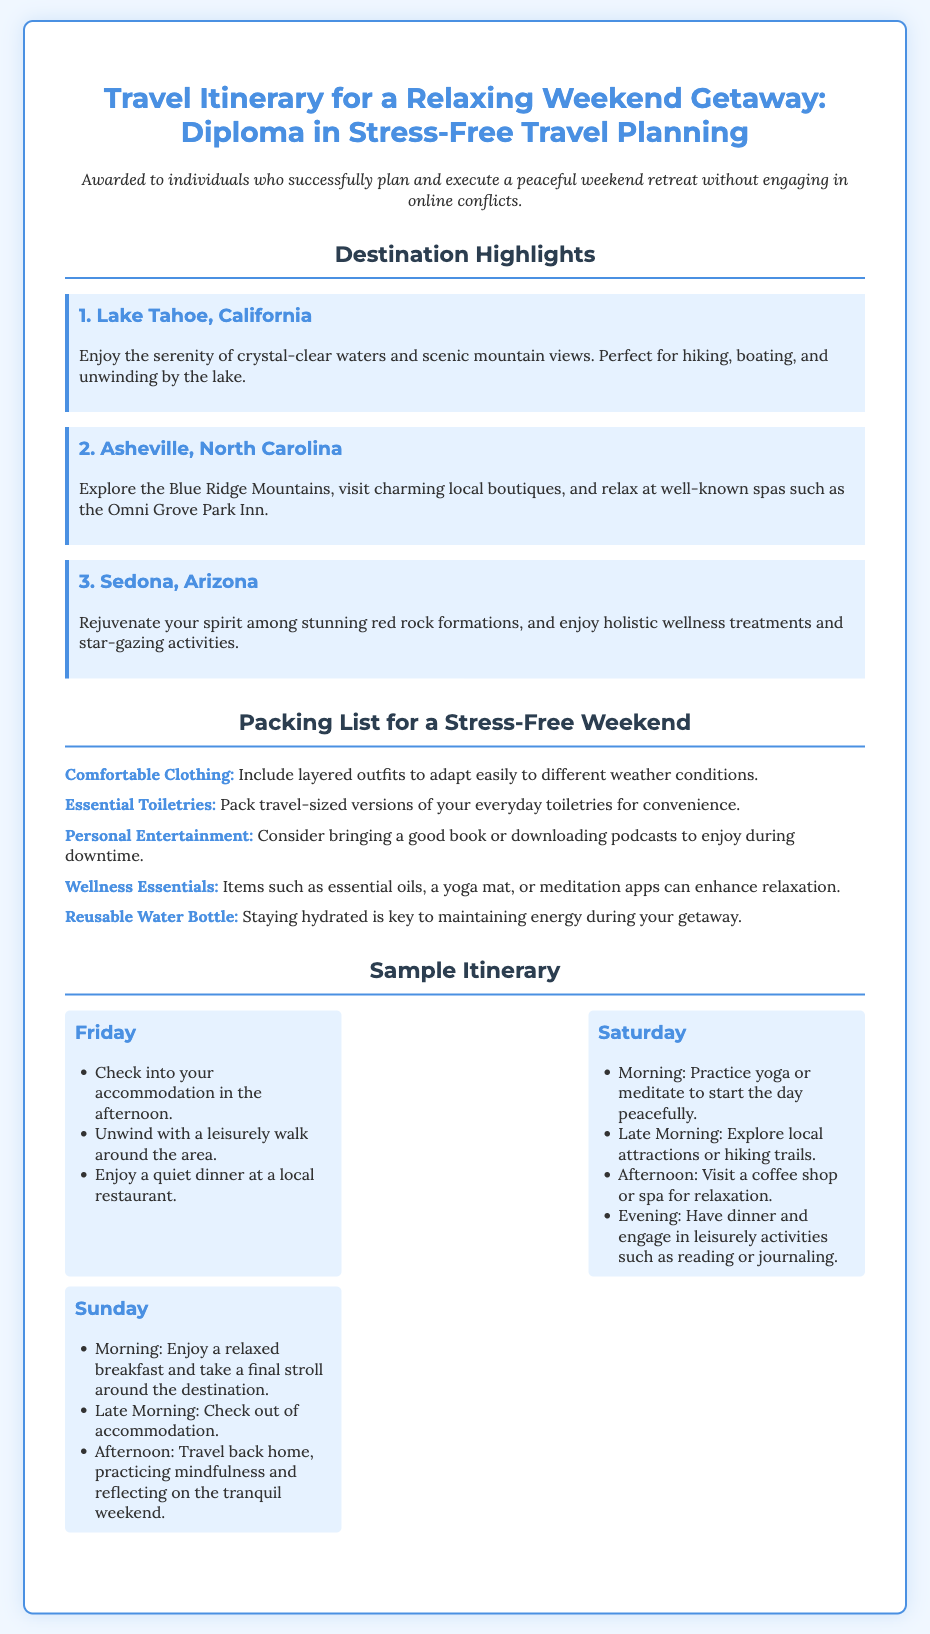What is the title of the document? The title is prominently displayed at the top of the document, indicating the subject of the content.
Answer: Travel Itinerary for a Relaxing Weekend Getaway: Diploma in Stress-Free Travel Planning How many destination highlights are listed? The document lists three specific destinations in the highlighted section.
Answer: 3 What is the first destination mentioned? The first destination is the initial focus on scenic locations within the document.
Answer: Lake Tahoe, California What is one of the wellness essentials to bring? The packing list provides a specific category of items for enhancing relaxation during the trip.
Answer: Essential oils On which day is yoga suggested? The itinerary includes specific activities for each day to promote relaxation and mindfulness.
Answer: Saturday What is a key activity planned for Sunday morning? This activity emphasizes taking time to relax and enjoy the surroundings before departing.
Answer: Enjoy a relaxed breakfast What should you consider packing for personal entertainment? The document suggests items for leisure during downtime, which is part of the packing list.
Answer: A good book How is the document styled? The styling details reflect the design elements incorporated to enhance its visual appeal and readability.
Answer: Stress-Free Travel Planning 